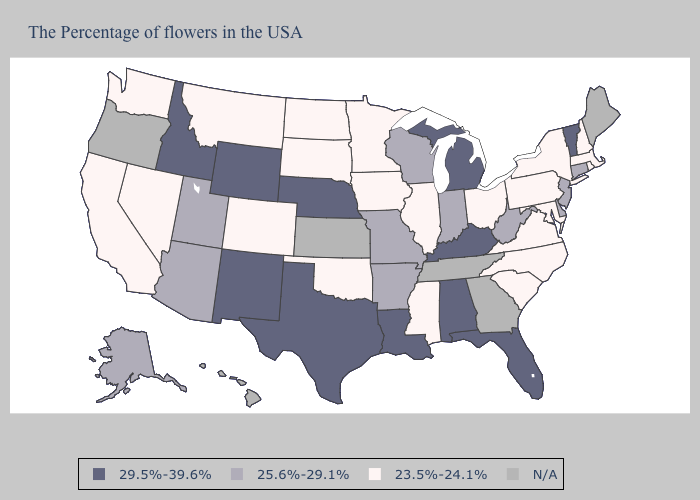Among the states that border Michigan , which have the highest value?
Concise answer only. Indiana, Wisconsin. Does Washington have the lowest value in the West?
Quick response, please. Yes. Does Nevada have the lowest value in the USA?
Keep it brief. Yes. Among the states that border Nevada , does Idaho have the highest value?
Answer briefly. Yes. What is the value of Nevada?
Concise answer only. 23.5%-24.1%. What is the value of Ohio?
Write a very short answer. 23.5%-24.1%. What is the lowest value in states that border Minnesota?
Keep it brief. 23.5%-24.1%. Does Wyoming have the highest value in the USA?
Concise answer only. Yes. Among the states that border Utah , which have the lowest value?
Write a very short answer. Colorado, Nevada. Name the states that have a value in the range 25.6%-29.1%?
Short answer required. Connecticut, New Jersey, Delaware, West Virginia, Indiana, Wisconsin, Missouri, Arkansas, Utah, Arizona, Alaska. Among the states that border Massachusetts , which have the lowest value?
Give a very brief answer. Rhode Island, New Hampshire, New York. What is the lowest value in states that border Florida?
Write a very short answer. 29.5%-39.6%. What is the highest value in the USA?
Give a very brief answer. 29.5%-39.6%. 